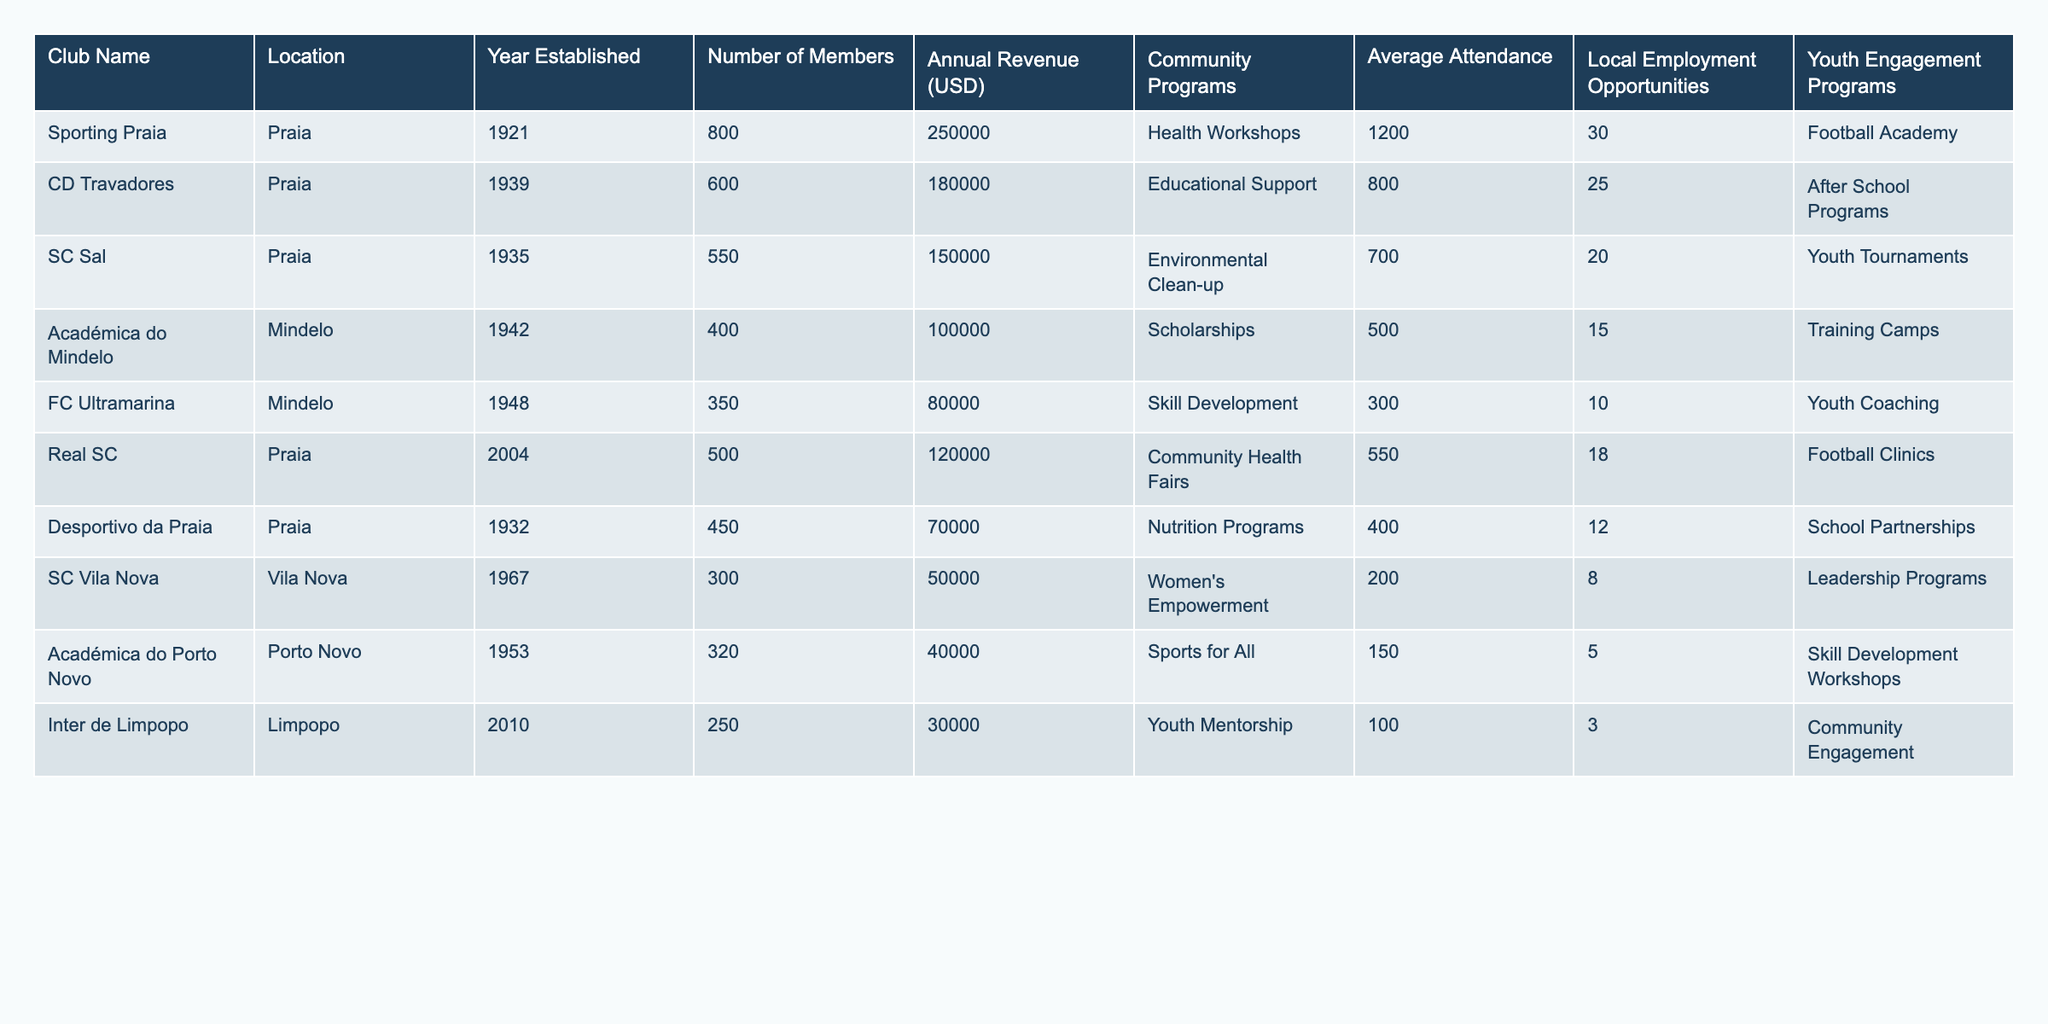What is the total annual revenue of all the clubs combined? To find the total annual revenue, sum the annual revenues of each club: 250000 + 180000 + 150000 + 100000 + 80000 + 120000 + 70000 + 50000 + 40000 + 30000 = 1180000
Answer: 1180000 Which club has the highest number of members? Looking at the "Number of Members" column, Sporting Praia has 800 members, which is higher than any other club listed.
Answer: Sporting Praia What community program is offered by Real SC? By checking the "Community Programs" column for Real SC, it shows that they offer "Community Health Fairs."
Answer: Community Health Fairs Is there any club that provides a football academy for youth? Examining the "Youth Engagement Programs" column reveals that Sporting Praia provides a "Football Academy" for youth.
Answer: Yes What is the average attendance across all clubs? First, sum the average attendance: 1200 + 800 + 700 + 500 + 300 + 550 + 400 + 200 + 150 + 100 = 4150. Then, divide by the number of clubs (10): 4150 / 10 = 415.
Answer: 415 How many clubs offer educational support programs? Only CD Travadores is listed as providing "Educational Support" under the "Community Programs" column.
Answer: 1 What percentage of members are engaged in youth programs across all clubs? For the total number of members, sum them: 800 + 600 + 550 + 400 + 350 + 500 + 450 + 300 + 320 + 250 = 4250. The total count of clubs with youth programs is 5 (Sporting Praia, CD Travadores, SC Sal, FC Ultramarina, Real SC), totaling 800 + 600 + 350 + 300 + 500 = 3050. Now calculate the percentage: (3050 / 4250) * 100 = 71.76%.
Answer: 71.76% Which location has the least number of clubs listed in the table? By looking at the "Location" column, Vila Nova has only 1 club (SC Vila Nova) while all other locations have more than 1 club.
Answer: Vila Nova Are there any clubs located in Mindelo? Checking the "Location" column shows that both Académica do Mindelo and FC Ultramarina are based in Mindelo.
Answer: Yes What is the difference in annual revenue between the club with the highest revenue and the club with the lowest revenue? The club with the highest revenue is Sporting Praia (250000), and the lowest is Académica do Porto Novo (40000). The difference is 250000 - 40000 = 210000.
Answer: 210000 What is the ratio of local employment opportunities between the club with the most opportunities and the one with the least? Sporting Praia has 30 local employment opportunities, while Inter de Limpopo has 3. The ratio is 30:3, which simplifies to 10:1.
Answer: 10:1 